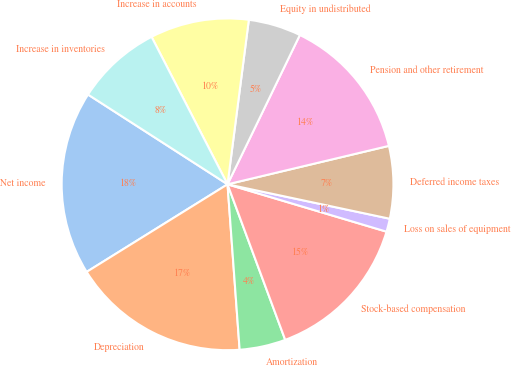Convert chart. <chart><loc_0><loc_0><loc_500><loc_500><pie_chart><fcel>Net income<fcel>Depreciation<fcel>Amortization<fcel>Stock-based compensation<fcel>Loss on sales of equipment<fcel>Deferred income taxes<fcel>Pension and other retirement<fcel>Equity in undistributed<fcel>Increase in accounts<fcel>Increase in inventories<nl><fcel>17.95%<fcel>17.31%<fcel>4.49%<fcel>14.74%<fcel>1.28%<fcel>7.05%<fcel>14.1%<fcel>5.13%<fcel>9.62%<fcel>8.33%<nl></chart> 